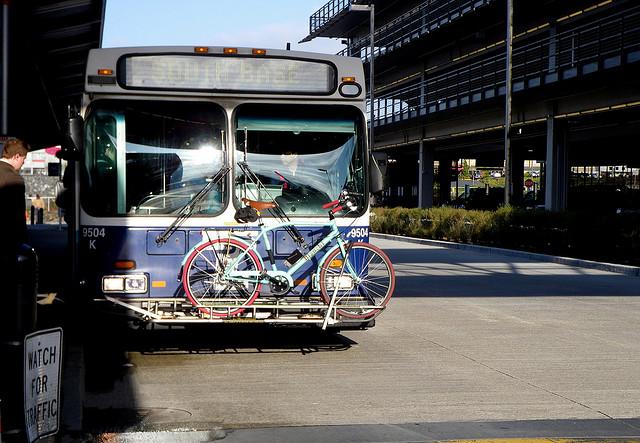What does the white sign say?
Concise answer only. Watch for traffic. What is on front of the bus?
Be succinct. Bike. What color is the bus?
Write a very short answer. Blue. 